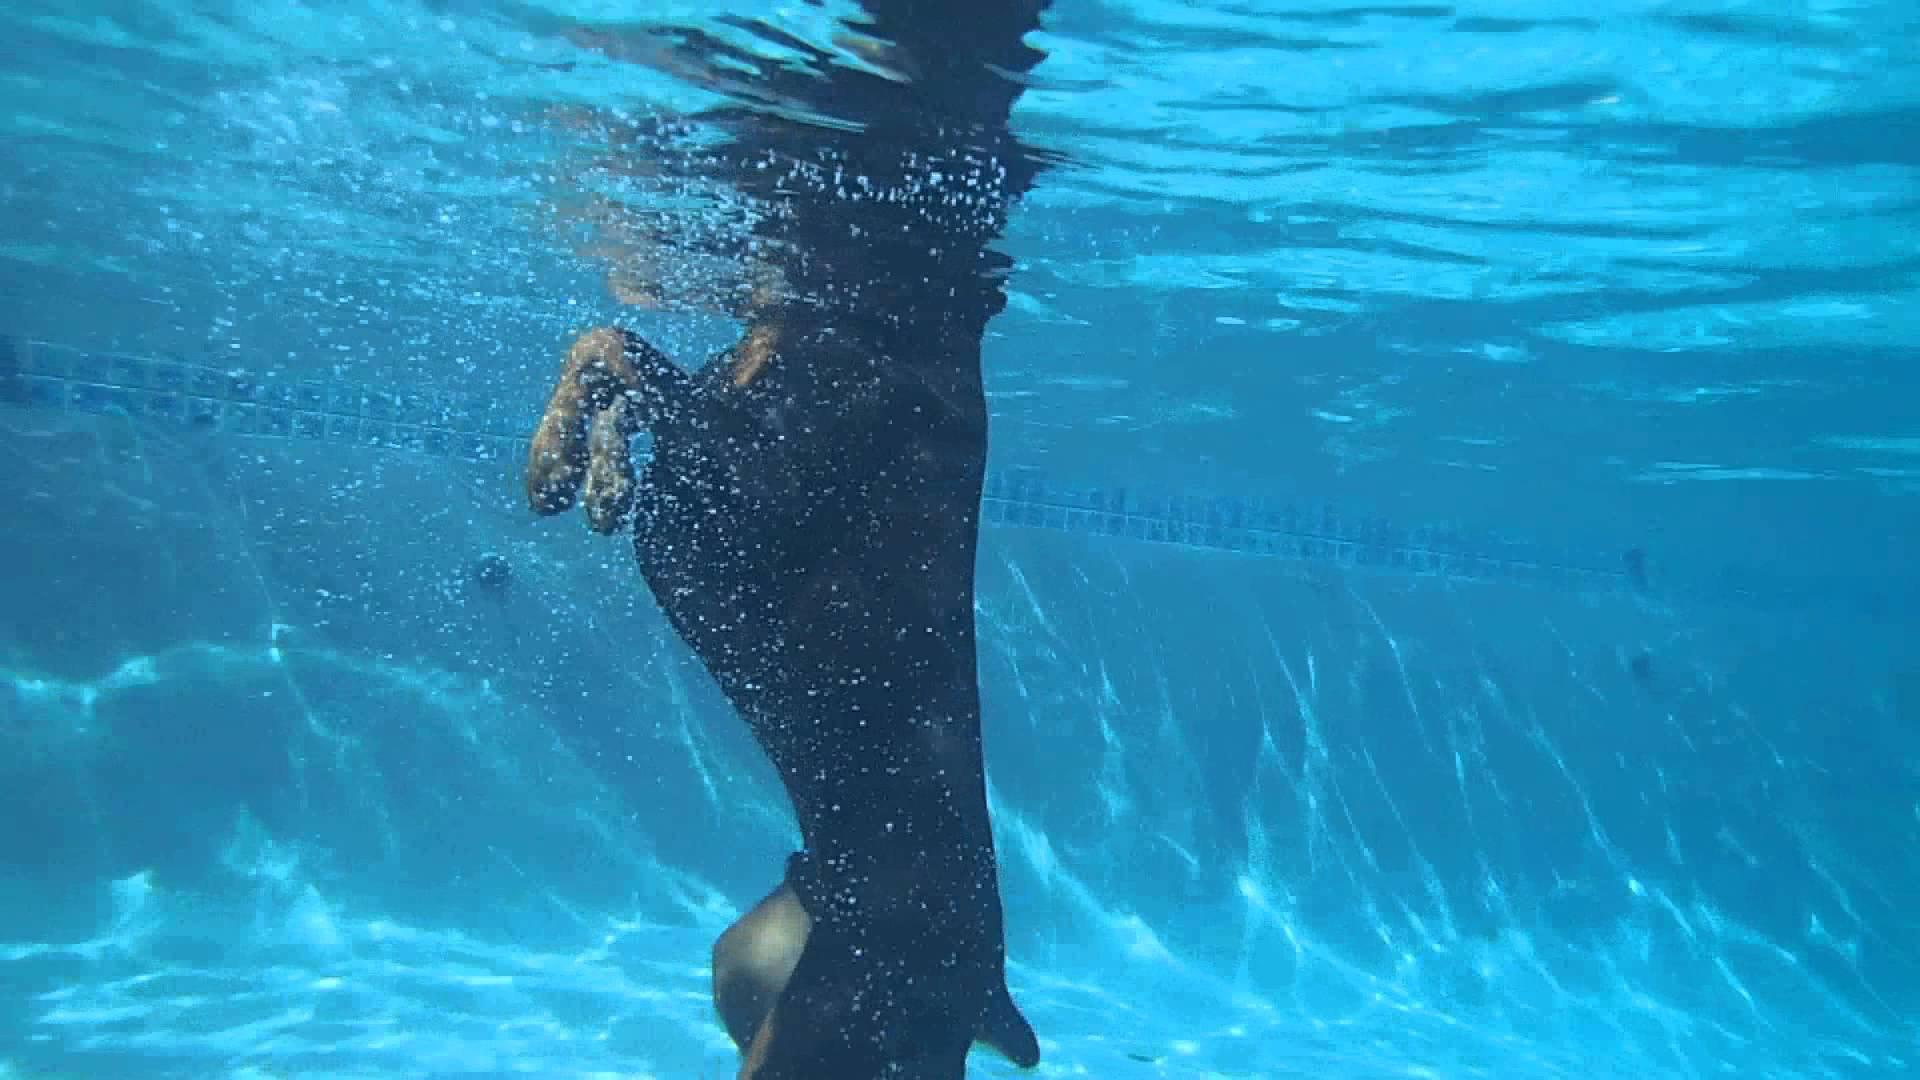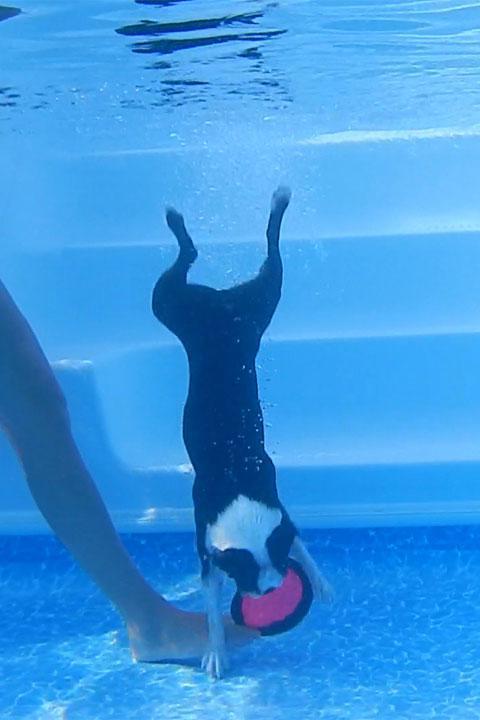The first image is the image on the left, the second image is the image on the right. Considering the images on both sides, is "The left and right image contains the same number of dogs with at least one dog grabbing a frisbee." valid? Answer yes or no. Yes. The first image is the image on the left, the second image is the image on the right. For the images displayed, is the sentence "An image shows a doberman underwater with his muzzle pointed downward just above a flat object." factually correct? Answer yes or no. No. 